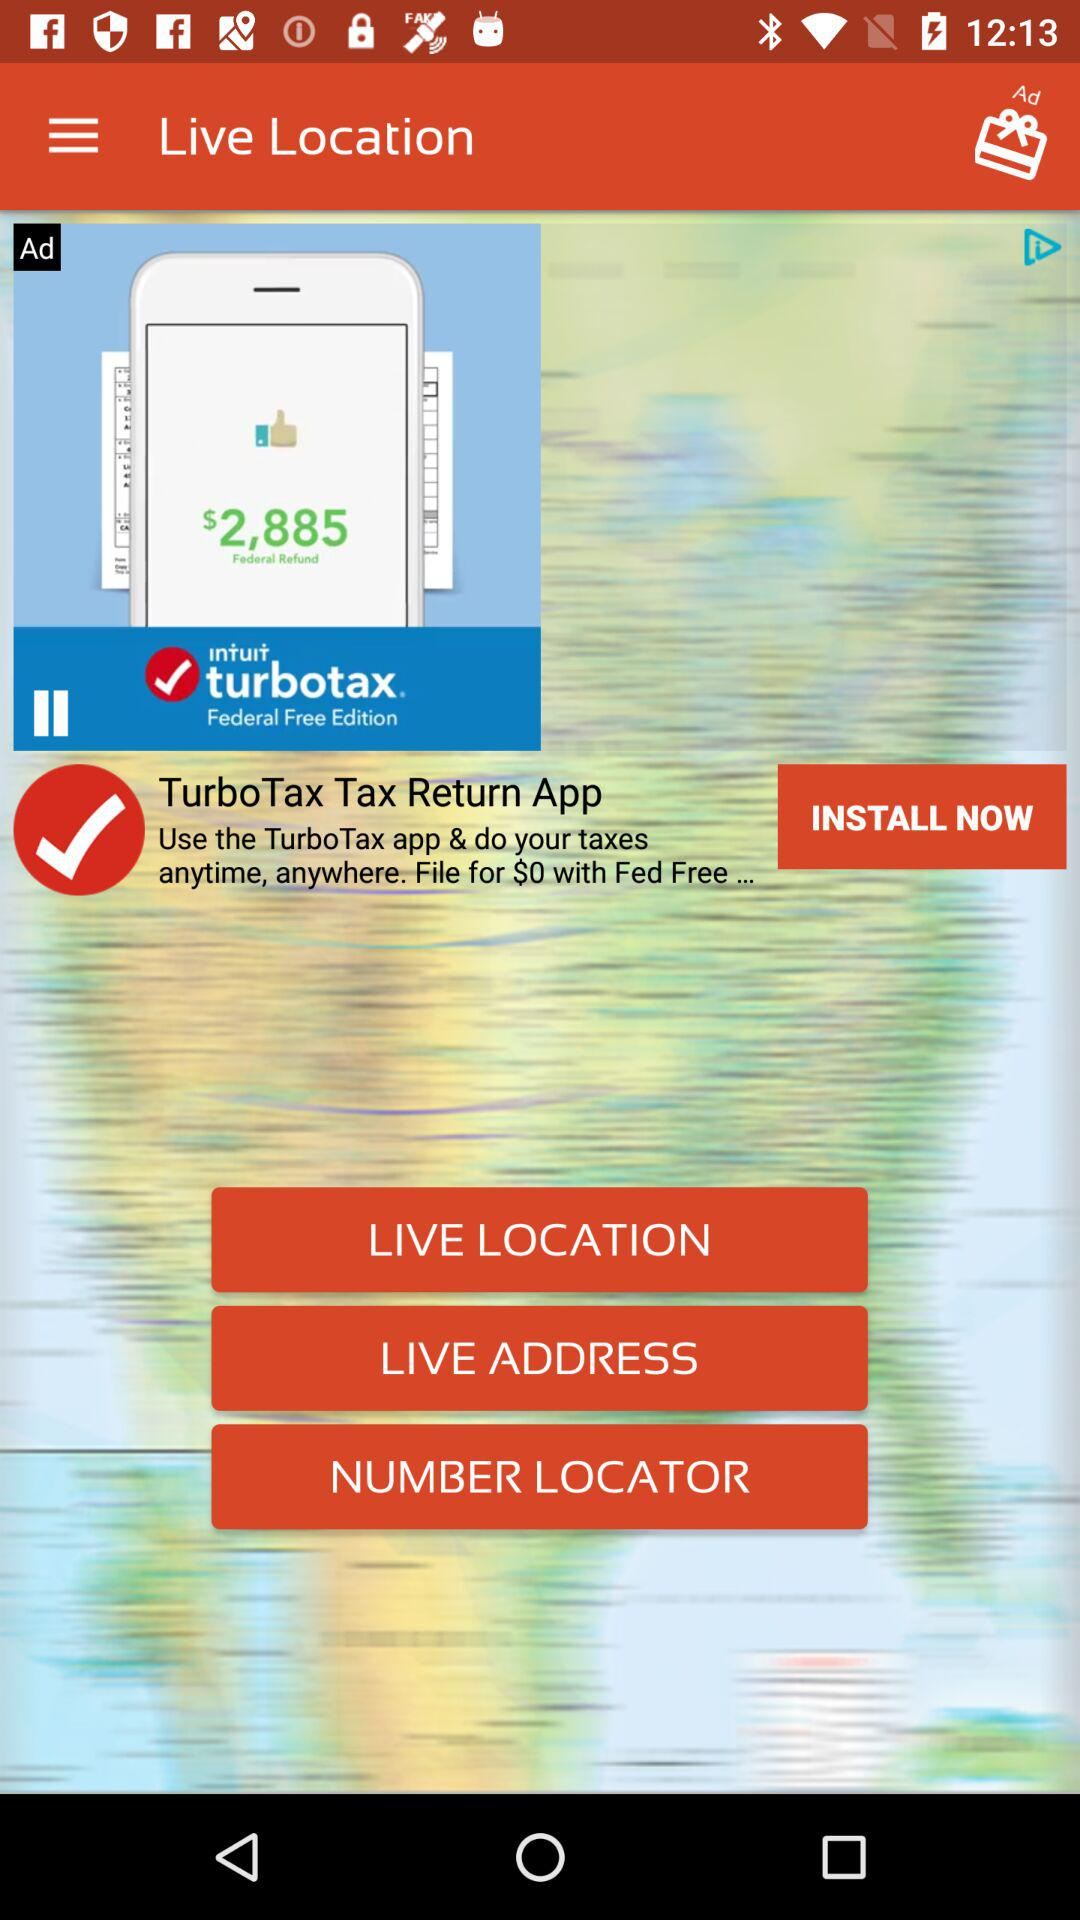What is the application name? The application name is "Live Location". 